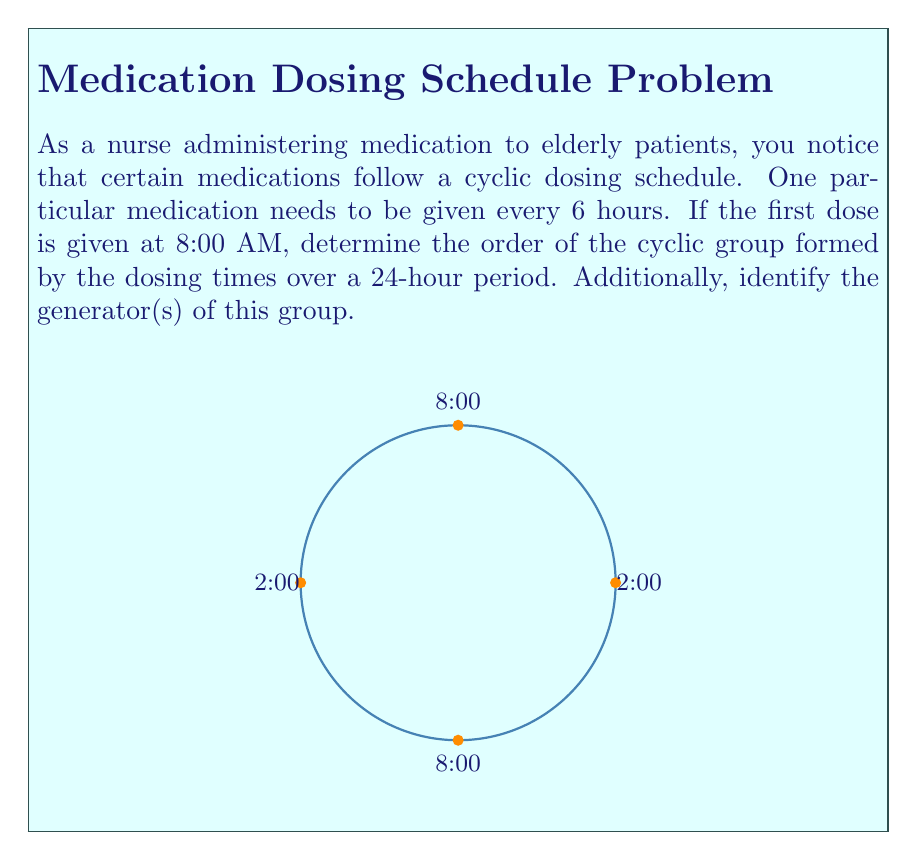Teach me how to tackle this problem. Let's approach this step-by-step:

1) First, let's identify the elements of the group. The medication is given every 6 hours, starting at 8:00 AM. Over a 24-hour period, the dosing times will be:
   8:00 AM, 2:00 PM, 8:00 PM, 2:00 AM

2) We can represent these times as elements of a group:
   $e$ = 8:00 AM (identity element)
   $a$ = 2:00 PM
   $a^2$ = 8:00 PM
   $a^3$ = 2:00 AM

3) The group operation is "advancing time by 6 hours". We can see that:
   $a^4 = e$ (after advancing 24 hours, we're back to the start)

4) This forms a cyclic group of order 4, which is isomorphic to $\mathbb{Z}_4$ (the group of integers modulo 4 under addition).

5) To determine the order of the group, we count the number of distinct elements: 4

6) To identify the generator(s), we need to find element(s) that can generate all other elements:
   - $a$ generates the whole group: $\{e, a, a^2, a^3\}$
   - $a^3$ also generates the whole group: $\{e, a^3, a^2, a\}$

7) $a^2$ is not a generator as it only generates $\{e, a^2\}$

Therefore, the generators of this group are $a$ (2:00 PM) and $a^3$ (2:00 AM).
Answer: Order: 4; Generators: 2:00 PM and 2:00 AM 